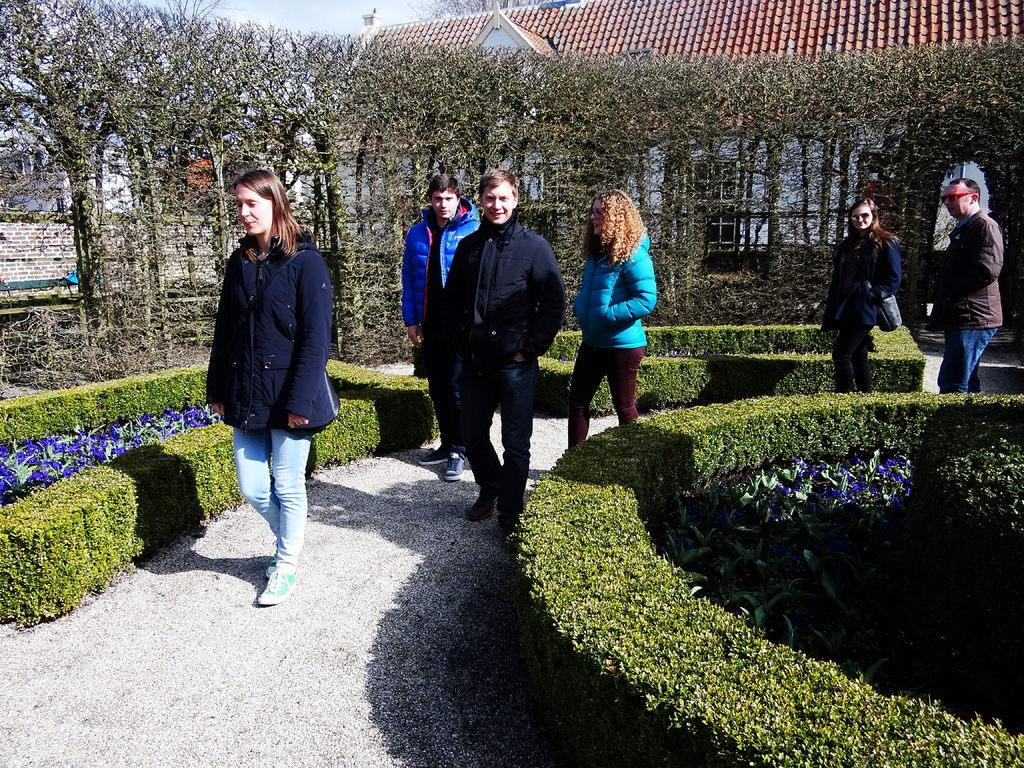How many people are in the image? There are three people in the image. What are the people doing in the image? The people are walking in a garden. What can be seen in the background of the image? There are trees and buildings in the background of the image. What type of ink is used on the canvas in the image? There is no canvas or ink present in the image; it features three people walking in a garden. 